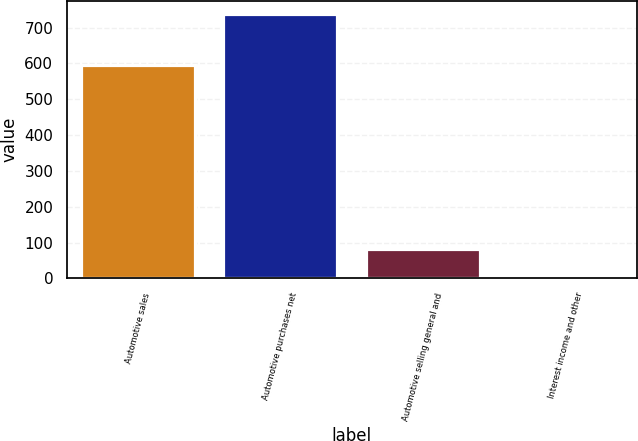<chart> <loc_0><loc_0><loc_500><loc_500><bar_chart><fcel>Automotive sales<fcel>Automotive purchases net<fcel>Automotive selling general and<fcel>Interest income and other<nl><fcel>596<fcel>737<fcel>81.8<fcel>9<nl></chart> 